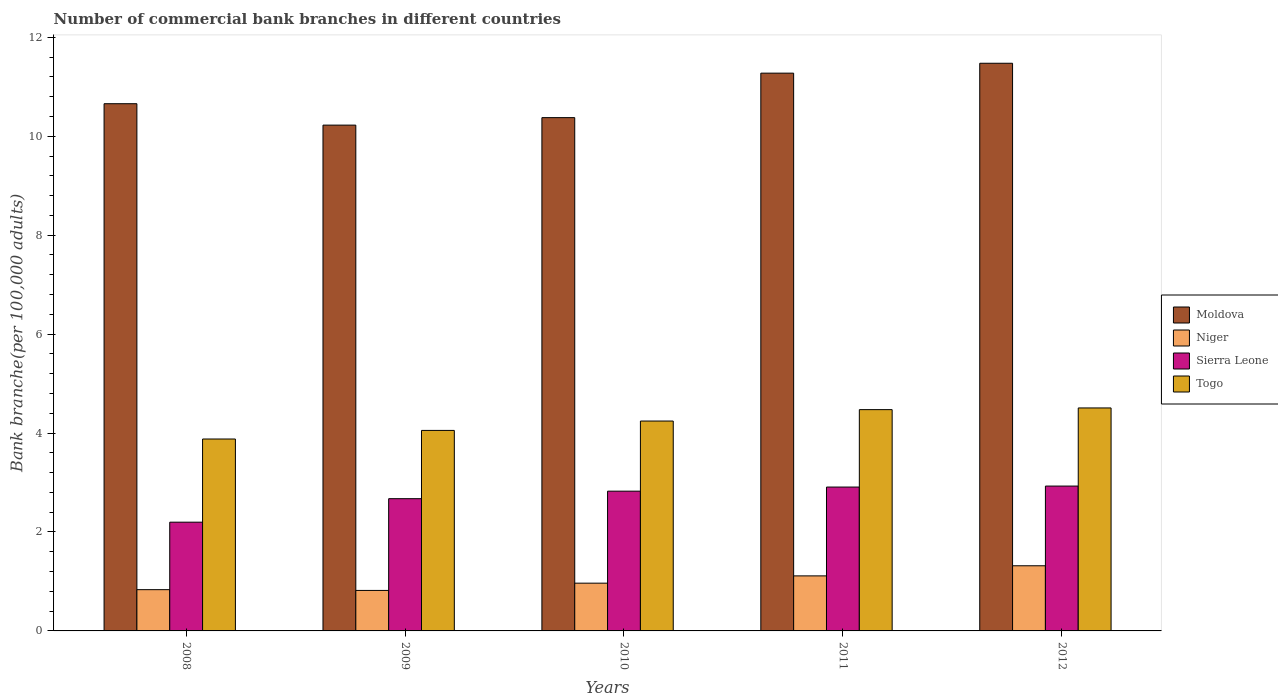How many different coloured bars are there?
Your response must be concise. 4. Are the number of bars per tick equal to the number of legend labels?
Offer a terse response. Yes. How many bars are there on the 1st tick from the left?
Your answer should be very brief. 4. How many bars are there on the 3rd tick from the right?
Your response must be concise. 4. What is the number of commercial bank branches in Sierra Leone in 2008?
Give a very brief answer. 2.2. Across all years, what is the maximum number of commercial bank branches in Togo?
Give a very brief answer. 4.51. Across all years, what is the minimum number of commercial bank branches in Niger?
Give a very brief answer. 0.82. What is the total number of commercial bank branches in Niger in the graph?
Your response must be concise. 5.05. What is the difference between the number of commercial bank branches in Moldova in 2009 and that in 2012?
Offer a very short reply. -1.25. What is the difference between the number of commercial bank branches in Togo in 2009 and the number of commercial bank branches in Niger in 2012?
Your answer should be compact. 2.74. What is the average number of commercial bank branches in Moldova per year?
Provide a short and direct response. 10.8. In the year 2011, what is the difference between the number of commercial bank branches in Moldova and number of commercial bank branches in Sierra Leone?
Offer a very short reply. 8.37. What is the ratio of the number of commercial bank branches in Niger in 2010 to that in 2012?
Give a very brief answer. 0.73. What is the difference between the highest and the second highest number of commercial bank branches in Moldova?
Give a very brief answer. 0.2. What is the difference between the highest and the lowest number of commercial bank branches in Moldova?
Your response must be concise. 1.25. In how many years, is the number of commercial bank branches in Moldova greater than the average number of commercial bank branches in Moldova taken over all years?
Your response must be concise. 2. Is the sum of the number of commercial bank branches in Sierra Leone in 2011 and 2012 greater than the maximum number of commercial bank branches in Moldova across all years?
Your answer should be very brief. No. What does the 2nd bar from the left in 2010 represents?
Your answer should be very brief. Niger. What does the 1st bar from the right in 2008 represents?
Your response must be concise. Togo. What is the difference between two consecutive major ticks on the Y-axis?
Offer a very short reply. 2. Are the values on the major ticks of Y-axis written in scientific E-notation?
Your answer should be compact. No. Does the graph contain any zero values?
Offer a very short reply. No. What is the title of the graph?
Give a very brief answer. Number of commercial bank branches in different countries. Does "Denmark" appear as one of the legend labels in the graph?
Your response must be concise. No. What is the label or title of the Y-axis?
Provide a succinct answer. Bank branche(per 100,0 adults). What is the Bank branche(per 100,000 adults) in Moldova in 2008?
Ensure brevity in your answer.  10.66. What is the Bank branche(per 100,000 adults) of Niger in 2008?
Keep it short and to the point. 0.83. What is the Bank branche(per 100,000 adults) of Sierra Leone in 2008?
Your answer should be very brief. 2.2. What is the Bank branche(per 100,000 adults) of Togo in 2008?
Your answer should be very brief. 3.88. What is the Bank branche(per 100,000 adults) in Moldova in 2009?
Your answer should be very brief. 10.23. What is the Bank branche(per 100,000 adults) of Niger in 2009?
Ensure brevity in your answer.  0.82. What is the Bank branche(per 100,000 adults) of Sierra Leone in 2009?
Give a very brief answer. 2.67. What is the Bank branche(per 100,000 adults) of Togo in 2009?
Make the answer very short. 4.05. What is the Bank branche(per 100,000 adults) of Moldova in 2010?
Ensure brevity in your answer.  10.38. What is the Bank branche(per 100,000 adults) in Niger in 2010?
Keep it short and to the point. 0.97. What is the Bank branche(per 100,000 adults) of Sierra Leone in 2010?
Provide a short and direct response. 2.83. What is the Bank branche(per 100,000 adults) in Togo in 2010?
Provide a succinct answer. 4.24. What is the Bank branche(per 100,000 adults) in Moldova in 2011?
Give a very brief answer. 11.28. What is the Bank branche(per 100,000 adults) of Niger in 2011?
Provide a succinct answer. 1.11. What is the Bank branche(per 100,000 adults) in Sierra Leone in 2011?
Provide a succinct answer. 2.91. What is the Bank branche(per 100,000 adults) in Togo in 2011?
Your answer should be compact. 4.47. What is the Bank branche(per 100,000 adults) in Moldova in 2012?
Your response must be concise. 11.48. What is the Bank branche(per 100,000 adults) in Niger in 2012?
Offer a very short reply. 1.32. What is the Bank branche(per 100,000 adults) in Sierra Leone in 2012?
Offer a very short reply. 2.93. What is the Bank branche(per 100,000 adults) of Togo in 2012?
Ensure brevity in your answer.  4.51. Across all years, what is the maximum Bank branche(per 100,000 adults) of Moldova?
Keep it short and to the point. 11.48. Across all years, what is the maximum Bank branche(per 100,000 adults) of Niger?
Your answer should be very brief. 1.32. Across all years, what is the maximum Bank branche(per 100,000 adults) in Sierra Leone?
Make the answer very short. 2.93. Across all years, what is the maximum Bank branche(per 100,000 adults) in Togo?
Your answer should be compact. 4.51. Across all years, what is the minimum Bank branche(per 100,000 adults) of Moldova?
Your response must be concise. 10.23. Across all years, what is the minimum Bank branche(per 100,000 adults) in Niger?
Keep it short and to the point. 0.82. Across all years, what is the minimum Bank branche(per 100,000 adults) in Sierra Leone?
Your answer should be very brief. 2.2. Across all years, what is the minimum Bank branche(per 100,000 adults) in Togo?
Your response must be concise. 3.88. What is the total Bank branche(per 100,000 adults) of Moldova in the graph?
Provide a short and direct response. 54.01. What is the total Bank branche(per 100,000 adults) of Niger in the graph?
Offer a terse response. 5.05. What is the total Bank branche(per 100,000 adults) in Sierra Leone in the graph?
Offer a terse response. 13.53. What is the total Bank branche(per 100,000 adults) of Togo in the graph?
Keep it short and to the point. 21.16. What is the difference between the Bank branche(per 100,000 adults) of Moldova in 2008 and that in 2009?
Provide a short and direct response. 0.43. What is the difference between the Bank branche(per 100,000 adults) in Niger in 2008 and that in 2009?
Provide a succinct answer. 0.02. What is the difference between the Bank branche(per 100,000 adults) of Sierra Leone in 2008 and that in 2009?
Ensure brevity in your answer.  -0.48. What is the difference between the Bank branche(per 100,000 adults) in Togo in 2008 and that in 2009?
Keep it short and to the point. -0.17. What is the difference between the Bank branche(per 100,000 adults) in Moldova in 2008 and that in 2010?
Keep it short and to the point. 0.28. What is the difference between the Bank branche(per 100,000 adults) of Niger in 2008 and that in 2010?
Ensure brevity in your answer.  -0.13. What is the difference between the Bank branche(per 100,000 adults) in Sierra Leone in 2008 and that in 2010?
Ensure brevity in your answer.  -0.63. What is the difference between the Bank branche(per 100,000 adults) in Togo in 2008 and that in 2010?
Offer a very short reply. -0.36. What is the difference between the Bank branche(per 100,000 adults) of Moldova in 2008 and that in 2011?
Give a very brief answer. -0.62. What is the difference between the Bank branche(per 100,000 adults) of Niger in 2008 and that in 2011?
Provide a succinct answer. -0.28. What is the difference between the Bank branche(per 100,000 adults) in Sierra Leone in 2008 and that in 2011?
Your answer should be compact. -0.71. What is the difference between the Bank branche(per 100,000 adults) in Togo in 2008 and that in 2011?
Your response must be concise. -0.59. What is the difference between the Bank branche(per 100,000 adults) in Moldova in 2008 and that in 2012?
Offer a terse response. -0.82. What is the difference between the Bank branche(per 100,000 adults) in Niger in 2008 and that in 2012?
Ensure brevity in your answer.  -0.48. What is the difference between the Bank branche(per 100,000 adults) of Sierra Leone in 2008 and that in 2012?
Offer a terse response. -0.73. What is the difference between the Bank branche(per 100,000 adults) of Togo in 2008 and that in 2012?
Your response must be concise. -0.63. What is the difference between the Bank branche(per 100,000 adults) of Moldova in 2009 and that in 2010?
Your response must be concise. -0.15. What is the difference between the Bank branche(per 100,000 adults) in Niger in 2009 and that in 2010?
Keep it short and to the point. -0.15. What is the difference between the Bank branche(per 100,000 adults) in Sierra Leone in 2009 and that in 2010?
Your answer should be very brief. -0.15. What is the difference between the Bank branche(per 100,000 adults) in Togo in 2009 and that in 2010?
Give a very brief answer. -0.19. What is the difference between the Bank branche(per 100,000 adults) of Moldova in 2009 and that in 2011?
Offer a terse response. -1.05. What is the difference between the Bank branche(per 100,000 adults) in Niger in 2009 and that in 2011?
Your response must be concise. -0.29. What is the difference between the Bank branche(per 100,000 adults) in Sierra Leone in 2009 and that in 2011?
Give a very brief answer. -0.23. What is the difference between the Bank branche(per 100,000 adults) in Togo in 2009 and that in 2011?
Your answer should be very brief. -0.42. What is the difference between the Bank branche(per 100,000 adults) in Moldova in 2009 and that in 2012?
Your answer should be very brief. -1.25. What is the difference between the Bank branche(per 100,000 adults) of Niger in 2009 and that in 2012?
Make the answer very short. -0.5. What is the difference between the Bank branche(per 100,000 adults) in Sierra Leone in 2009 and that in 2012?
Offer a very short reply. -0.25. What is the difference between the Bank branche(per 100,000 adults) of Togo in 2009 and that in 2012?
Ensure brevity in your answer.  -0.45. What is the difference between the Bank branche(per 100,000 adults) in Moldova in 2010 and that in 2011?
Offer a terse response. -0.9. What is the difference between the Bank branche(per 100,000 adults) of Niger in 2010 and that in 2011?
Offer a terse response. -0.15. What is the difference between the Bank branche(per 100,000 adults) of Sierra Leone in 2010 and that in 2011?
Provide a short and direct response. -0.08. What is the difference between the Bank branche(per 100,000 adults) of Togo in 2010 and that in 2011?
Offer a very short reply. -0.23. What is the difference between the Bank branche(per 100,000 adults) of Moldova in 2010 and that in 2012?
Provide a short and direct response. -1.1. What is the difference between the Bank branche(per 100,000 adults) in Niger in 2010 and that in 2012?
Your answer should be compact. -0.35. What is the difference between the Bank branche(per 100,000 adults) of Sierra Leone in 2010 and that in 2012?
Ensure brevity in your answer.  -0.1. What is the difference between the Bank branche(per 100,000 adults) of Togo in 2010 and that in 2012?
Offer a very short reply. -0.26. What is the difference between the Bank branche(per 100,000 adults) in Niger in 2011 and that in 2012?
Offer a very short reply. -0.2. What is the difference between the Bank branche(per 100,000 adults) of Sierra Leone in 2011 and that in 2012?
Your answer should be compact. -0.02. What is the difference between the Bank branche(per 100,000 adults) in Togo in 2011 and that in 2012?
Your answer should be very brief. -0.03. What is the difference between the Bank branche(per 100,000 adults) of Moldova in 2008 and the Bank branche(per 100,000 adults) of Niger in 2009?
Ensure brevity in your answer.  9.84. What is the difference between the Bank branche(per 100,000 adults) of Moldova in 2008 and the Bank branche(per 100,000 adults) of Sierra Leone in 2009?
Provide a succinct answer. 7.98. What is the difference between the Bank branche(per 100,000 adults) in Moldova in 2008 and the Bank branche(per 100,000 adults) in Togo in 2009?
Keep it short and to the point. 6.6. What is the difference between the Bank branche(per 100,000 adults) in Niger in 2008 and the Bank branche(per 100,000 adults) in Sierra Leone in 2009?
Your answer should be very brief. -1.84. What is the difference between the Bank branche(per 100,000 adults) in Niger in 2008 and the Bank branche(per 100,000 adults) in Togo in 2009?
Make the answer very short. -3.22. What is the difference between the Bank branche(per 100,000 adults) in Sierra Leone in 2008 and the Bank branche(per 100,000 adults) in Togo in 2009?
Make the answer very short. -1.86. What is the difference between the Bank branche(per 100,000 adults) in Moldova in 2008 and the Bank branche(per 100,000 adults) in Niger in 2010?
Keep it short and to the point. 9.69. What is the difference between the Bank branche(per 100,000 adults) of Moldova in 2008 and the Bank branche(per 100,000 adults) of Sierra Leone in 2010?
Your answer should be compact. 7.83. What is the difference between the Bank branche(per 100,000 adults) in Moldova in 2008 and the Bank branche(per 100,000 adults) in Togo in 2010?
Provide a short and direct response. 6.42. What is the difference between the Bank branche(per 100,000 adults) in Niger in 2008 and the Bank branche(per 100,000 adults) in Sierra Leone in 2010?
Provide a short and direct response. -1.99. What is the difference between the Bank branche(per 100,000 adults) in Niger in 2008 and the Bank branche(per 100,000 adults) in Togo in 2010?
Provide a succinct answer. -3.41. What is the difference between the Bank branche(per 100,000 adults) in Sierra Leone in 2008 and the Bank branche(per 100,000 adults) in Togo in 2010?
Provide a short and direct response. -2.04. What is the difference between the Bank branche(per 100,000 adults) in Moldova in 2008 and the Bank branche(per 100,000 adults) in Niger in 2011?
Keep it short and to the point. 9.55. What is the difference between the Bank branche(per 100,000 adults) of Moldova in 2008 and the Bank branche(per 100,000 adults) of Sierra Leone in 2011?
Provide a short and direct response. 7.75. What is the difference between the Bank branche(per 100,000 adults) of Moldova in 2008 and the Bank branche(per 100,000 adults) of Togo in 2011?
Provide a short and direct response. 6.18. What is the difference between the Bank branche(per 100,000 adults) in Niger in 2008 and the Bank branche(per 100,000 adults) in Sierra Leone in 2011?
Give a very brief answer. -2.07. What is the difference between the Bank branche(per 100,000 adults) of Niger in 2008 and the Bank branche(per 100,000 adults) of Togo in 2011?
Your answer should be compact. -3.64. What is the difference between the Bank branche(per 100,000 adults) in Sierra Leone in 2008 and the Bank branche(per 100,000 adults) in Togo in 2011?
Give a very brief answer. -2.28. What is the difference between the Bank branche(per 100,000 adults) in Moldova in 2008 and the Bank branche(per 100,000 adults) in Niger in 2012?
Ensure brevity in your answer.  9.34. What is the difference between the Bank branche(per 100,000 adults) of Moldova in 2008 and the Bank branche(per 100,000 adults) of Sierra Leone in 2012?
Your response must be concise. 7.73. What is the difference between the Bank branche(per 100,000 adults) in Moldova in 2008 and the Bank branche(per 100,000 adults) in Togo in 2012?
Give a very brief answer. 6.15. What is the difference between the Bank branche(per 100,000 adults) in Niger in 2008 and the Bank branche(per 100,000 adults) in Sierra Leone in 2012?
Keep it short and to the point. -2.09. What is the difference between the Bank branche(per 100,000 adults) of Niger in 2008 and the Bank branche(per 100,000 adults) of Togo in 2012?
Your answer should be compact. -3.67. What is the difference between the Bank branche(per 100,000 adults) of Sierra Leone in 2008 and the Bank branche(per 100,000 adults) of Togo in 2012?
Your response must be concise. -2.31. What is the difference between the Bank branche(per 100,000 adults) in Moldova in 2009 and the Bank branche(per 100,000 adults) in Niger in 2010?
Ensure brevity in your answer.  9.26. What is the difference between the Bank branche(per 100,000 adults) of Moldova in 2009 and the Bank branche(per 100,000 adults) of Sierra Leone in 2010?
Make the answer very short. 7.4. What is the difference between the Bank branche(per 100,000 adults) in Moldova in 2009 and the Bank branche(per 100,000 adults) in Togo in 2010?
Provide a succinct answer. 5.98. What is the difference between the Bank branche(per 100,000 adults) of Niger in 2009 and the Bank branche(per 100,000 adults) of Sierra Leone in 2010?
Offer a very short reply. -2.01. What is the difference between the Bank branche(per 100,000 adults) of Niger in 2009 and the Bank branche(per 100,000 adults) of Togo in 2010?
Keep it short and to the point. -3.42. What is the difference between the Bank branche(per 100,000 adults) in Sierra Leone in 2009 and the Bank branche(per 100,000 adults) in Togo in 2010?
Your answer should be compact. -1.57. What is the difference between the Bank branche(per 100,000 adults) in Moldova in 2009 and the Bank branche(per 100,000 adults) in Niger in 2011?
Offer a very short reply. 9.11. What is the difference between the Bank branche(per 100,000 adults) in Moldova in 2009 and the Bank branche(per 100,000 adults) in Sierra Leone in 2011?
Make the answer very short. 7.32. What is the difference between the Bank branche(per 100,000 adults) in Moldova in 2009 and the Bank branche(per 100,000 adults) in Togo in 2011?
Offer a terse response. 5.75. What is the difference between the Bank branche(per 100,000 adults) of Niger in 2009 and the Bank branche(per 100,000 adults) of Sierra Leone in 2011?
Offer a terse response. -2.09. What is the difference between the Bank branche(per 100,000 adults) of Niger in 2009 and the Bank branche(per 100,000 adults) of Togo in 2011?
Make the answer very short. -3.65. What is the difference between the Bank branche(per 100,000 adults) in Sierra Leone in 2009 and the Bank branche(per 100,000 adults) in Togo in 2011?
Keep it short and to the point. -1.8. What is the difference between the Bank branche(per 100,000 adults) in Moldova in 2009 and the Bank branche(per 100,000 adults) in Niger in 2012?
Offer a terse response. 8.91. What is the difference between the Bank branche(per 100,000 adults) in Moldova in 2009 and the Bank branche(per 100,000 adults) in Sierra Leone in 2012?
Provide a succinct answer. 7.3. What is the difference between the Bank branche(per 100,000 adults) in Moldova in 2009 and the Bank branche(per 100,000 adults) in Togo in 2012?
Provide a short and direct response. 5.72. What is the difference between the Bank branche(per 100,000 adults) in Niger in 2009 and the Bank branche(per 100,000 adults) in Sierra Leone in 2012?
Ensure brevity in your answer.  -2.11. What is the difference between the Bank branche(per 100,000 adults) in Niger in 2009 and the Bank branche(per 100,000 adults) in Togo in 2012?
Make the answer very short. -3.69. What is the difference between the Bank branche(per 100,000 adults) in Sierra Leone in 2009 and the Bank branche(per 100,000 adults) in Togo in 2012?
Keep it short and to the point. -1.83. What is the difference between the Bank branche(per 100,000 adults) in Moldova in 2010 and the Bank branche(per 100,000 adults) in Niger in 2011?
Your answer should be very brief. 9.26. What is the difference between the Bank branche(per 100,000 adults) of Moldova in 2010 and the Bank branche(per 100,000 adults) of Sierra Leone in 2011?
Give a very brief answer. 7.47. What is the difference between the Bank branche(per 100,000 adults) of Moldova in 2010 and the Bank branche(per 100,000 adults) of Togo in 2011?
Your answer should be compact. 5.9. What is the difference between the Bank branche(per 100,000 adults) in Niger in 2010 and the Bank branche(per 100,000 adults) in Sierra Leone in 2011?
Your answer should be very brief. -1.94. What is the difference between the Bank branche(per 100,000 adults) of Niger in 2010 and the Bank branche(per 100,000 adults) of Togo in 2011?
Keep it short and to the point. -3.51. What is the difference between the Bank branche(per 100,000 adults) in Sierra Leone in 2010 and the Bank branche(per 100,000 adults) in Togo in 2011?
Offer a terse response. -1.65. What is the difference between the Bank branche(per 100,000 adults) of Moldova in 2010 and the Bank branche(per 100,000 adults) of Niger in 2012?
Your answer should be compact. 9.06. What is the difference between the Bank branche(per 100,000 adults) in Moldova in 2010 and the Bank branche(per 100,000 adults) in Sierra Leone in 2012?
Ensure brevity in your answer.  7.45. What is the difference between the Bank branche(per 100,000 adults) of Moldova in 2010 and the Bank branche(per 100,000 adults) of Togo in 2012?
Keep it short and to the point. 5.87. What is the difference between the Bank branche(per 100,000 adults) of Niger in 2010 and the Bank branche(per 100,000 adults) of Sierra Leone in 2012?
Offer a terse response. -1.96. What is the difference between the Bank branche(per 100,000 adults) in Niger in 2010 and the Bank branche(per 100,000 adults) in Togo in 2012?
Give a very brief answer. -3.54. What is the difference between the Bank branche(per 100,000 adults) of Sierra Leone in 2010 and the Bank branche(per 100,000 adults) of Togo in 2012?
Ensure brevity in your answer.  -1.68. What is the difference between the Bank branche(per 100,000 adults) in Moldova in 2011 and the Bank branche(per 100,000 adults) in Niger in 2012?
Provide a succinct answer. 9.96. What is the difference between the Bank branche(per 100,000 adults) in Moldova in 2011 and the Bank branche(per 100,000 adults) in Sierra Leone in 2012?
Ensure brevity in your answer.  8.35. What is the difference between the Bank branche(per 100,000 adults) of Moldova in 2011 and the Bank branche(per 100,000 adults) of Togo in 2012?
Keep it short and to the point. 6.77. What is the difference between the Bank branche(per 100,000 adults) of Niger in 2011 and the Bank branche(per 100,000 adults) of Sierra Leone in 2012?
Make the answer very short. -1.82. What is the difference between the Bank branche(per 100,000 adults) in Niger in 2011 and the Bank branche(per 100,000 adults) in Togo in 2012?
Ensure brevity in your answer.  -3.4. What is the difference between the Bank branche(per 100,000 adults) in Sierra Leone in 2011 and the Bank branche(per 100,000 adults) in Togo in 2012?
Provide a short and direct response. -1.6. What is the average Bank branche(per 100,000 adults) in Moldova per year?
Ensure brevity in your answer.  10.8. What is the average Bank branche(per 100,000 adults) of Niger per year?
Offer a very short reply. 1.01. What is the average Bank branche(per 100,000 adults) in Sierra Leone per year?
Ensure brevity in your answer.  2.71. What is the average Bank branche(per 100,000 adults) of Togo per year?
Your response must be concise. 4.23. In the year 2008, what is the difference between the Bank branche(per 100,000 adults) of Moldova and Bank branche(per 100,000 adults) of Niger?
Offer a very short reply. 9.82. In the year 2008, what is the difference between the Bank branche(per 100,000 adults) in Moldova and Bank branche(per 100,000 adults) in Sierra Leone?
Your answer should be compact. 8.46. In the year 2008, what is the difference between the Bank branche(per 100,000 adults) in Moldova and Bank branche(per 100,000 adults) in Togo?
Give a very brief answer. 6.78. In the year 2008, what is the difference between the Bank branche(per 100,000 adults) of Niger and Bank branche(per 100,000 adults) of Sierra Leone?
Your answer should be compact. -1.36. In the year 2008, what is the difference between the Bank branche(per 100,000 adults) in Niger and Bank branche(per 100,000 adults) in Togo?
Provide a short and direct response. -3.05. In the year 2008, what is the difference between the Bank branche(per 100,000 adults) of Sierra Leone and Bank branche(per 100,000 adults) of Togo?
Make the answer very short. -1.68. In the year 2009, what is the difference between the Bank branche(per 100,000 adults) in Moldova and Bank branche(per 100,000 adults) in Niger?
Your answer should be compact. 9.41. In the year 2009, what is the difference between the Bank branche(per 100,000 adults) of Moldova and Bank branche(per 100,000 adults) of Sierra Leone?
Give a very brief answer. 7.55. In the year 2009, what is the difference between the Bank branche(per 100,000 adults) of Moldova and Bank branche(per 100,000 adults) of Togo?
Offer a terse response. 6.17. In the year 2009, what is the difference between the Bank branche(per 100,000 adults) of Niger and Bank branche(per 100,000 adults) of Sierra Leone?
Provide a succinct answer. -1.85. In the year 2009, what is the difference between the Bank branche(per 100,000 adults) of Niger and Bank branche(per 100,000 adults) of Togo?
Your response must be concise. -3.23. In the year 2009, what is the difference between the Bank branche(per 100,000 adults) of Sierra Leone and Bank branche(per 100,000 adults) of Togo?
Your response must be concise. -1.38. In the year 2010, what is the difference between the Bank branche(per 100,000 adults) of Moldova and Bank branche(per 100,000 adults) of Niger?
Offer a very short reply. 9.41. In the year 2010, what is the difference between the Bank branche(per 100,000 adults) of Moldova and Bank branche(per 100,000 adults) of Sierra Leone?
Your answer should be very brief. 7.55. In the year 2010, what is the difference between the Bank branche(per 100,000 adults) of Moldova and Bank branche(per 100,000 adults) of Togo?
Offer a terse response. 6.13. In the year 2010, what is the difference between the Bank branche(per 100,000 adults) in Niger and Bank branche(per 100,000 adults) in Sierra Leone?
Your answer should be compact. -1.86. In the year 2010, what is the difference between the Bank branche(per 100,000 adults) of Niger and Bank branche(per 100,000 adults) of Togo?
Ensure brevity in your answer.  -3.28. In the year 2010, what is the difference between the Bank branche(per 100,000 adults) of Sierra Leone and Bank branche(per 100,000 adults) of Togo?
Make the answer very short. -1.42. In the year 2011, what is the difference between the Bank branche(per 100,000 adults) of Moldova and Bank branche(per 100,000 adults) of Niger?
Your response must be concise. 10.16. In the year 2011, what is the difference between the Bank branche(per 100,000 adults) in Moldova and Bank branche(per 100,000 adults) in Sierra Leone?
Your answer should be very brief. 8.37. In the year 2011, what is the difference between the Bank branche(per 100,000 adults) of Moldova and Bank branche(per 100,000 adults) of Togo?
Provide a succinct answer. 6.8. In the year 2011, what is the difference between the Bank branche(per 100,000 adults) of Niger and Bank branche(per 100,000 adults) of Sierra Leone?
Offer a terse response. -1.8. In the year 2011, what is the difference between the Bank branche(per 100,000 adults) in Niger and Bank branche(per 100,000 adults) in Togo?
Ensure brevity in your answer.  -3.36. In the year 2011, what is the difference between the Bank branche(per 100,000 adults) in Sierra Leone and Bank branche(per 100,000 adults) in Togo?
Provide a short and direct response. -1.57. In the year 2012, what is the difference between the Bank branche(per 100,000 adults) of Moldova and Bank branche(per 100,000 adults) of Niger?
Provide a succinct answer. 10.16. In the year 2012, what is the difference between the Bank branche(per 100,000 adults) of Moldova and Bank branche(per 100,000 adults) of Sierra Leone?
Provide a short and direct response. 8.55. In the year 2012, what is the difference between the Bank branche(per 100,000 adults) of Moldova and Bank branche(per 100,000 adults) of Togo?
Your response must be concise. 6.97. In the year 2012, what is the difference between the Bank branche(per 100,000 adults) of Niger and Bank branche(per 100,000 adults) of Sierra Leone?
Your answer should be very brief. -1.61. In the year 2012, what is the difference between the Bank branche(per 100,000 adults) of Niger and Bank branche(per 100,000 adults) of Togo?
Offer a very short reply. -3.19. In the year 2012, what is the difference between the Bank branche(per 100,000 adults) in Sierra Leone and Bank branche(per 100,000 adults) in Togo?
Provide a succinct answer. -1.58. What is the ratio of the Bank branche(per 100,000 adults) in Moldova in 2008 to that in 2009?
Your answer should be compact. 1.04. What is the ratio of the Bank branche(per 100,000 adults) in Niger in 2008 to that in 2009?
Your response must be concise. 1.02. What is the ratio of the Bank branche(per 100,000 adults) in Sierra Leone in 2008 to that in 2009?
Offer a very short reply. 0.82. What is the ratio of the Bank branche(per 100,000 adults) in Togo in 2008 to that in 2009?
Your response must be concise. 0.96. What is the ratio of the Bank branche(per 100,000 adults) in Moldova in 2008 to that in 2010?
Provide a succinct answer. 1.03. What is the ratio of the Bank branche(per 100,000 adults) of Niger in 2008 to that in 2010?
Give a very brief answer. 0.86. What is the ratio of the Bank branche(per 100,000 adults) in Sierra Leone in 2008 to that in 2010?
Give a very brief answer. 0.78. What is the ratio of the Bank branche(per 100,000 adults) in Togo in 2008 to that in 2010?
Your answer should be very brief. 0.91. What is the ratio of the Bank branche(per 100,000 adults) of Moldova in 2008 to that in 2011?
Ensure brevity in your answer.  0.95. What is the ratio of the Bank branche(per 100,000 adults) of Niger in 2008 to that in 2011?
Offer a terse response. 0.75. What is the ratio of the Bank branche(per 100,000 adults) in Sierra Leone in 2008 to that in 2011?
Provide a short and direct response. 0.76. What is the ratio of the Bank branche(per 100,000 adults) in Togo in 2008 to that in 2011?
Keep it short and to the point. 0.87. What is the ratio of the Bank branche(per 100,000 adults) in Moldova in 2008 to that in 2012?
Your response must be concise. 0.93. What is the ratio of the Bank branche(per 100,000 adults) of Niger in 2008 to that in 2012?
Your response must be concise. 0.63. What is the ratio of the Bank branche(per 100,000 adults) of Sierra Leone in 2008 to that in 2012?
Make the answer very short. 0.75. What is the ratio of the Bank branche(per 100,000 adults) of Togo in 2008 to that in 2012?
Offer a terse response. 0.86. What is the ratio of the Bank branche(per 100,000 adults) in Moldova in 2009 to that in 2010?
Make the answer very short. 0.99. What is the ratio of the Bank branche(per 100,000 adults) in Niger in 2009 to that in 2010?
Give a very brief answer. 0.85. What is the ratio of the Bank branche(per 100,000 adults) in Sierra Leone in 2009 to that in 2010?
Ensure brevity in your answer.  0.95. What is the ratio of the Bank branche(per 100,000 adults) in Togo in 2009 to that in 2010?
Give a very brief answer. 0.96. What is the ratio of the Bank branche(per 100,000 adults) in Moldova in 2009 to that in 2011?
Your answer should be very brief. 0.91. What is the ratio of the Bank branche(per 100,000 adults) in Niger in 2009 to that in 2011?
Make the answer very short. 0.74. What is the ratio of the Bank branche(per 100,000 adults) in Sierra Leone in 2009 to that in 2011?
Ensure brevity in your answer.  0.92. What is the ratio of the Bank branche(per 100,000 adults) in Togo in 2009 to that in 2011?
Give a very brief answer. 0.91. What is the ratio of the Bank branche(per 100,000 adults) of Moldova in 2009 to that in 2012?
Keep it short and to the point. 0.89. What is the ratio of the Bank branche(per 100,000 adults) of Niger in 2009 to that in 2012?
Keep it short and to the point. 0.62. What is the ratio of the Bank branche(per 100,000 adults) of Togo in 2009 to that in 2012?
Provide a short and direct response. 0.9. What is the ratio of the Bank branche(per 100,000 adults) in Moldova in 2010 to that in 2011?
Your answer should be very brief. 0.92. What is the ratio of the Bank branche(per 100,000 adults) in Niger in 2010 to that in 2011?
Ensure brevity in your answer.  0.87. What is the ratio of the Bank branche(per 100,000 adults) of Sierra Leone in 2010 to that in 2011?
Keep it short and to the point. 0.97. What is the ratio of the Bank branche(per 100,000 adults) of Togo in 2010 to that in 2011?
Ensure brevity in your answer.  0.95. What is the ratio of the Bank branche(per 100,000 adults) in Moldova in 2010 to that in 2012?
Your answer should be compact. 0.9. What is the ratio of the Bank branche(per 100,000 adults) of Niger in 2010 to that in 2012?
Provide a succinct answer. 0.73. What is the ratio of the Bank branche(per 100,000 adults) of Sierra Leone in 2010 to that in 2012?
Give a very brief answer. 0.96. What is the ratio of the Bank branche(per 100,000 adults) of Togo in 2010 to that in 2012?
Keep it short and to the point. 0.94. What is the ratio of the Bank branche(per 100,000 adults) of Moldova in 2011 to that in 2012?
Keep it short and to the point. 0.98. What is the ratio of the Bank branche(per 100,000 adults) in Niger in 2011 to that in 2012?
Offer a terse response. 0.84. What is the ratio of the Bank branche(per 100,000 adults) of Sierra Leone in 2011 to that in 2012?
Your answer should be compact. 0.99. What is the ratio of the Bank branche(per 100,000 adults) in Togo in 2011 to that in 2012?
Provide a succinct answer. 0.99. What is the difference between the highest and the second highest Bank branche(per 100,000 adults) in Moldova?
Your answer should be very brief. 0.2. What is the difference between the highest and the second highest Bank branche(per 100,000 adults) in Niger?
Ensure brevity in your answer.  0.2. What is the difference between the highest and the second highest Bank branche(per 100,000 adults) in Sierra Leone?
Your answer should be very brief. 0.02. What is the difference between the highest and the second highest Bank branche(per 100,000 adults) of Togo?
Your response must be concise. 0.03. What is the difference between the highest and the lowest Bank branche(per 100,000 adults) in Moldova?
Provide a short and direct response. 1.25. What is the difference between the highest and the lowest Bank branche(per 100,000 adults) of Niger?
Keep it short and to the point. 0.5. What is the difference between the highest and the lowest Bank branche(per 100,000 adults) of Sierra Leone?
Offer a very short reply. 0.73. What is the difference between the highest and the lowest Bank branche(per 100,000 adults) of Togo?
Provide a succinct answer. 0.63. 